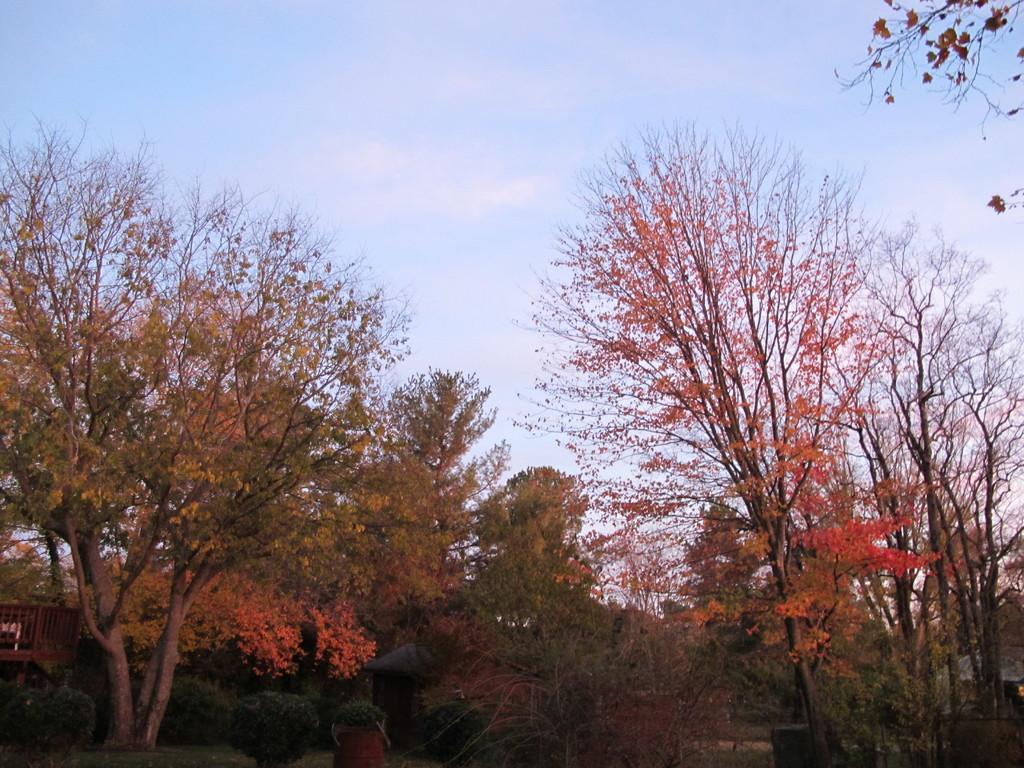Could you give a brief overview of what you see in this image? In this image I can see trees. In the background there is sky. Also there are some other objects. 